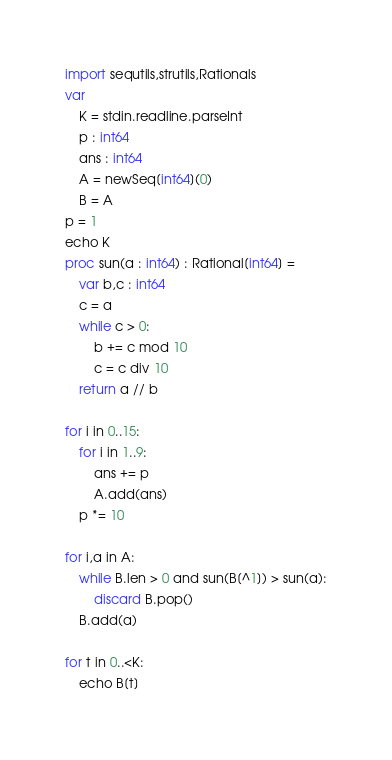Convert code to text. <code><loc_0><loc_0><loc_500><loc_500><_Nim_>import sequtils,strutils,Rationals
var
    K = stdin.readline.parseInt
    p : int64
    ans : int64
    A = newSeq[int64](0)
    B = A
p = 1
echo K
proc sun(a : int64) : Rational[int64] =
    var b,c : int64
    c = a
    while c > 0:
        b += c mod 10
        c = c div 10
    return a // b

for i in 0..15:
    for i in 1..9:
        ans += p
        A.add(ans)
    p *= 10
    
for i,a in A:
    while B.len > 0 and sun(B[^1]) > sun(a):
        discard B.pop()
    B.add(a)

for t in 0..<K:
    echo B[t]</code> 